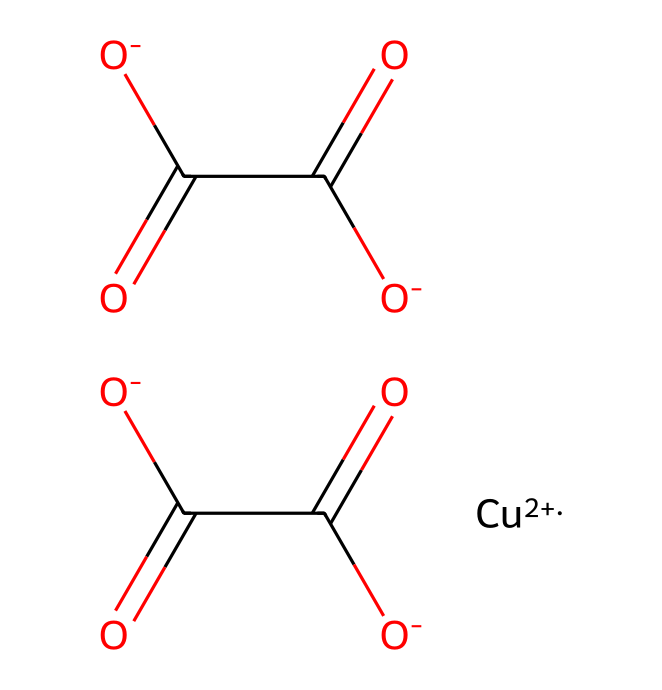how many copper ions are in the structure? The structure includes one copper ion represented by [Cu+2], which shows that there is a single copper atom with a +2 oxidation state.
Answer: one what is the oxidation state of copper in this compound? The notation [Cu+2] explicitly indicates that the copper ion has an oxidation number of +2.
Answer: +2 how many carboxylate groups are present in the structure? The chemical structure features two parts represented as [O-]C(=O)C([O-])=O, which indicates the presence of two carboxylate groups (deprotonated carboxylic acids) in the compound.
Answer: two what type of compound is verdigris? Verdigris is primarily known as a copper acetate, which is a type of pigment derived from the reaction of copper with acetic acid.
Answer: copper acetate what is the primary color associated with verdigris? The name verdigris is derived from the Latin term 'viridis,' meaning green, which reflects the pigment's distinctive green color.
Answer: green what type of bonding is present between copper and the carboxylate groups? The bonding is ionic due to the interaction between the positively charged copper ion and the negatively charged carboxylate groups.
Answer: ionic how is verdigris historically significant in the Renaissance? Verdigris was widely used as a green pigment in paintings and artworks during the Renaissance, contributing significantly to the color palette of that era's masterpieces.
Answer: significant pigment 